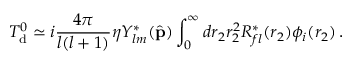Convert formula to latex. <formula><loc_0><loc_0><loc_500><loc_500>T _ { d } ^ { 0 } \simeq i { \frac { 4 \pi } { l ( l + 1 ) } } \eta Y _ { l m } ^ { * } ( { \hat { p } } ) \int _ { 0 } ^ { \infty } d r _ { 2 } r _ { 2 } ^ { 2 } R _ { f l } ^ { * } ( r _ { 2 } ) \phi _ { i } ( r _ { 2 } ) \, .</formula> 